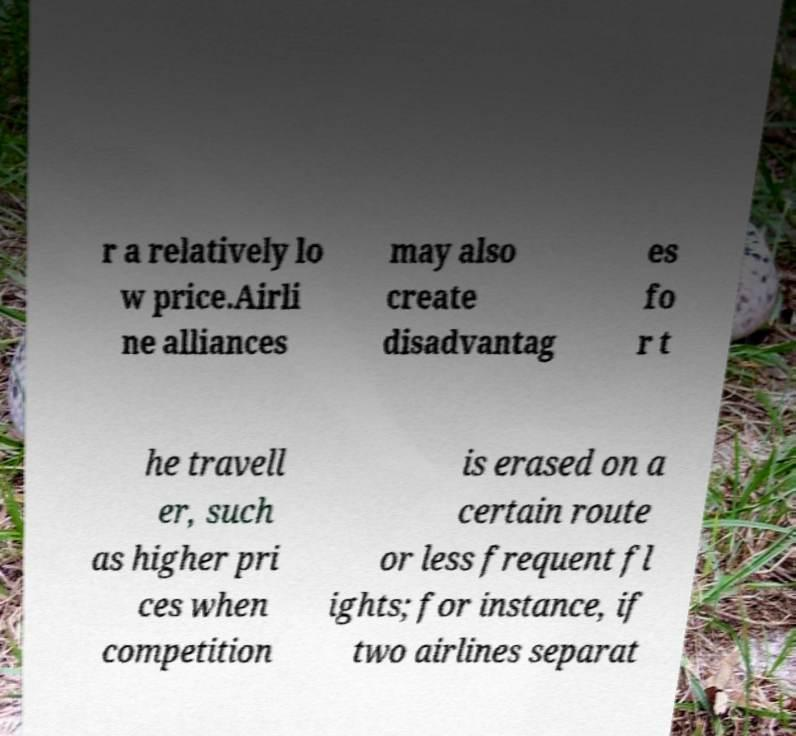Can you read and provide the text displayed in the image?This photo seems to have some interesting text. Can you extract and type it out for me? r a relatively lo w price.Airli ne alliances may also create disadvantag es fo r t he travell er, such as higher pri ces when competition is erased on a certain route or less frequent fl ights; for instance, if two airlines separat 